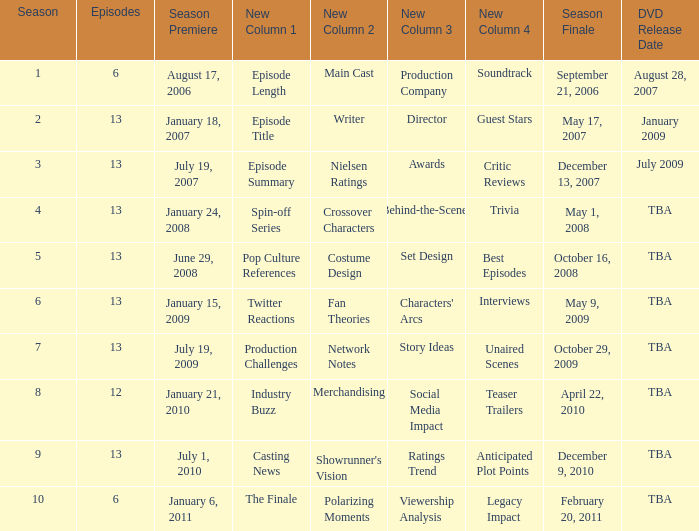Which season had fewer than 13 episodes and aired its season finale on February 20, 2011? 1.0. 